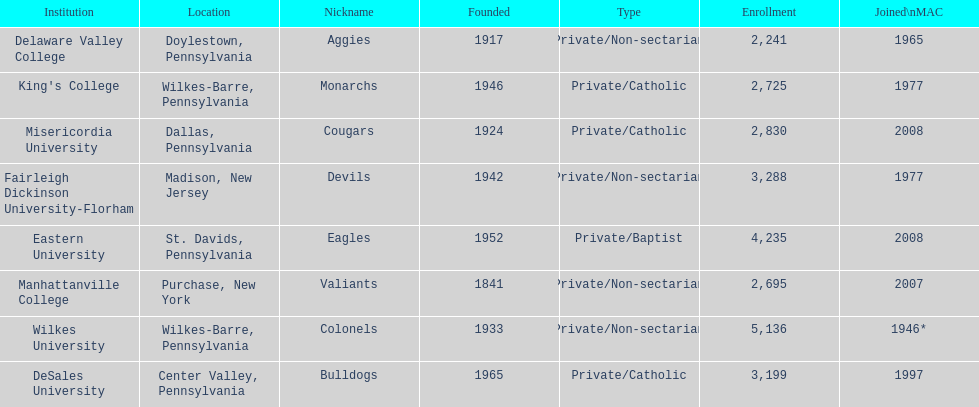Name each institution with enrollment numbers above 4,000? Eastern University, Wilkes University. 